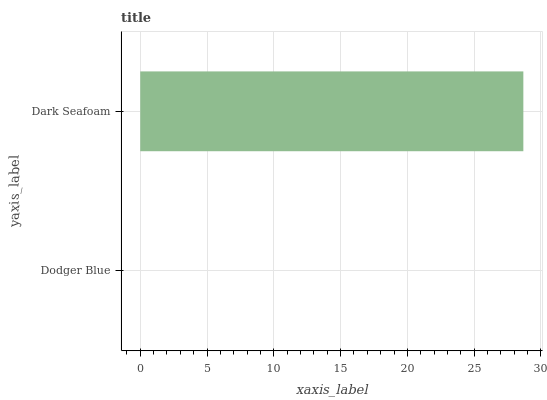Is Dodger Blue the minimum?
Answer yes or no. Yes. Is Dark Seafoam the maximum?
Answer yes or no. Yes. Is Dark Seafoam the minimum?
Answer yes or no. No. Is Dark Seafoam greater than Dodger Blue?
Answer yes or no. Yes. Is Dodger Blue less than Dark Seafoam?
Answer yes or no. Yes. Is Dodger Blue greater than Dark Seafoam?
Answer yes or no. No. Is Dark Seafoam less than Dodger Blue?
Answer yes or no. No. Is Dark Seafoam the high median?
Answer yes or no. Yes. Is Dodger Blue the low median?
Answer yes or no. Yes. Is Dodger Blue the high median?
Answer yes or no. No. Is Dark Seafoam the low median?
Answer yes or no. No. 